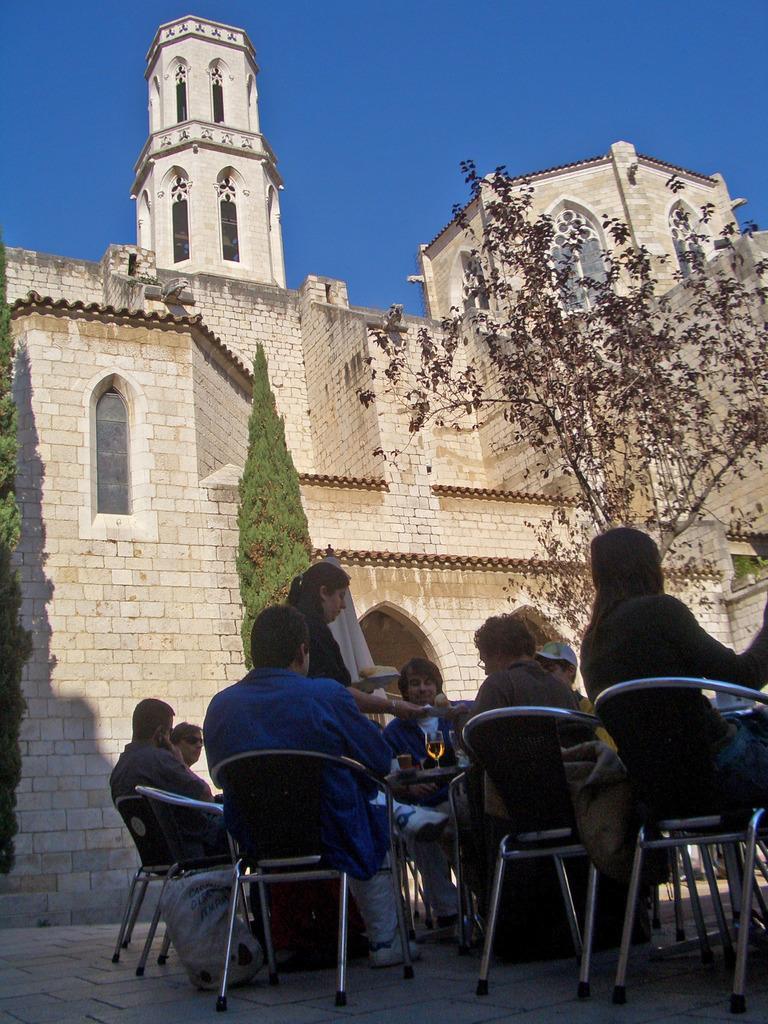In one or two sentences, can you explain what this image depicts? In this picture outside of the house. There is a group of people. They are sitting on a chairs. center of the person is standing. She is holding a plate. We can see in background tree,wall,window and sky. 